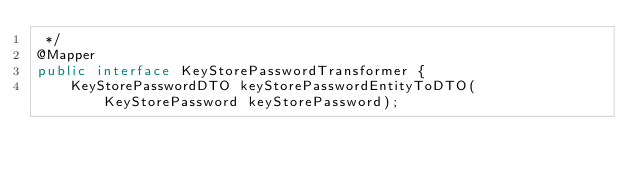Convert code to text. <code><loc_0><loc_0><loc_500><loc_500><_Java_> */
@Mapper
public interface KeyStorePasswordTransformer {
    KeyStorePasswordDTO keyStorePasswordEntityToDTO(KeyStorePassword keyStorePassword);
</code> 